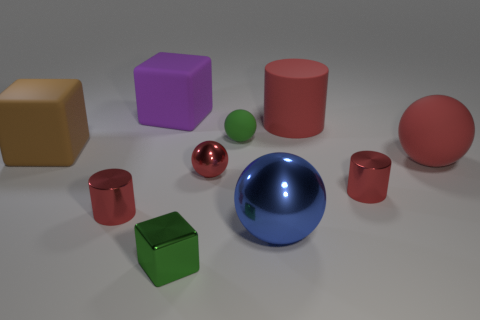Subtract all red cylinders. How many were subtracted if there are1red cylinders left? 2 Subtract all blue cylinders. How many red spheres are left? 2 Subtract all tiny shiny cubes. How many cubes are left? 2 Subtract 1 spheres. How many spheres are left? 3 Subtract all blue balls. How many balls are left? 3 Subtract all purple cylinders. Subtract all brown balls. How many cylinders are left? 3 Subtract 0 blue cylinders. How many objects are left? 10 Subtract all spheres. How many objects are left? 6 Subtract all matte balls. Subtract all tiny matte objects. How many objects are left? 7 Add 5 big rubber cylinders. How many big rubber cylinders are left? 6 